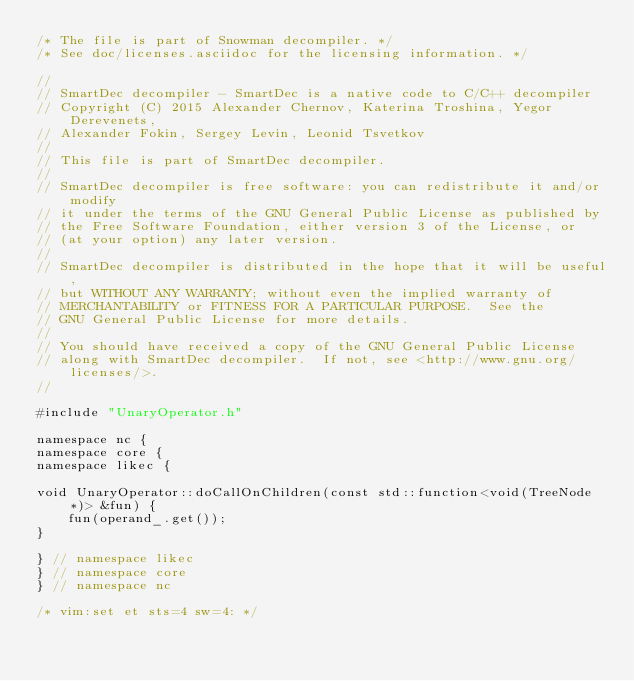<code> <loc_0><loc_0><loc_500><loc_500><_C++_>/* The file is part of Snowman decompiler. */
/* See doc/licenses.asciidoc for the licensing information. */

//
// SmartDec decompiler - SmartDec is a native code to C/C++ decompiler
// Copyright (C) 2015 Alexander Chernov, Katerina Troshina, Yegor Derevenets,
// Alexander Fokin, Sergey Levin, Leonid Tsvetkov
//
// This file is part of SmartDec decompiler.
//
// SmartDec decompiler is free software: you can redistribute it and/or modify
// it under the terms of the GNU General Public License as published by
// the Free Software Foundation, either version 3 of the License, or
// (at your option) any later version.
//
// SmartDec decompiler is distributed in the hope that it will be useful,
// but WITHOUT ANY WARRANTY; without even the implied warranty of
// MERCHANTABILITY or FITNESS FOR A PARTICULAR PURPOSE.  See the
// GNU General Public License for more details.
//
// You should have received a copy of the GNU General Public License
// along with SmartDec decompiler.  If not, see <http://www.gnu.org/licenses/>.
//

#include "UnaryOperator.h"

namespace nc {
namespace core {
namespace likec {

void UnaryOperator::doCallOnChildren(const std::function<void(TreeNode *)> &fun) {
    fun(operand_.get());
}

} // namespace likec
} // namespace core
} // namespace nc

/* vim:set et sts=4 sw=4: */
</code> 